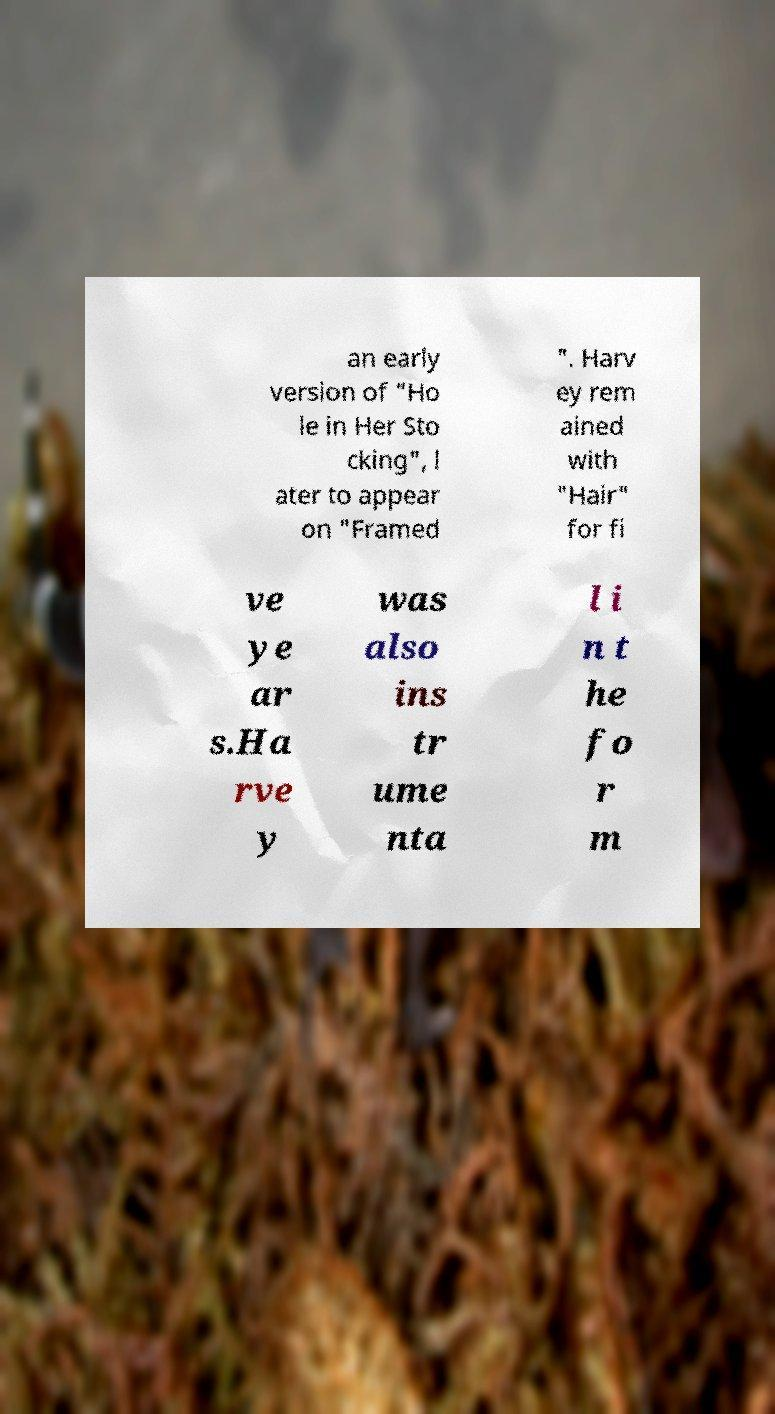For documentation purposes, I need the text within this image transcribed. Could you provide that? an early version of "Ho le in Her Sto cking", l ater to appear on "Framed ". Harv ey rem ained with "Hair" for fi ve ye ar s.Ha rve y was also ins tr ume nta l i n t he fo r m 